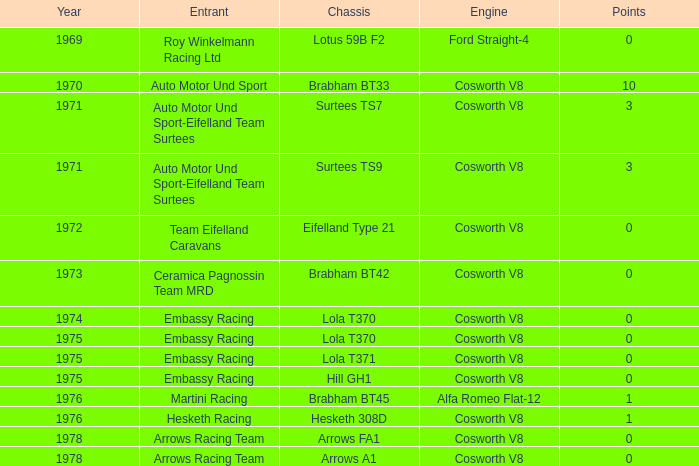What was the aggregate number of points in 1978 with a chassis of arrows fa1? 0.0. Could you parse the entire table as a dict? {'header': ['Year', 'Entrant', 'Chassis', 'Engine', 'Points'], 'rows': [['1969', 'Roy Winkelmann Racing Ltd', 'Lotus 59B F2', 'Ford Straight-4', '0'], ['1970', 'Auto Motor Und Sport', 'Brabham BT33', 'Cosworth V8', '10'], ['1971', 'Auto Motor Und Sport-Eifelland Team Surtees', 'Surtees TS7', 'Cosworth V8', '3'], ['1971', 'Auto Motor Und Sport-Eifelland Team Surtees', 'Surtees TS9', 'Cosworth V8', '3'], ['1972', 'Team Eifelland Caravans', 'Eifelland Type 21', 'Cosworth V8', '0'], ['1973', 'Ceramica Pagnossin Team MRD', 'Brabham BT42', 'Cosworth V8', '0'], ['1974', 'Embassy Racing', 'Lola T370', 'Cosworth V8', '0'], ['1975', 'Embassy Racing', 'Lola T370', 'Cosworth V8', '0'], ['1975', 'Embassy Racing', 'Lola T371', 'Cosworth V8', '0'], ['1975', 'Embassy Racing', 'Hill GH1', 'Cosworth V8', '0'], ['1976', 'Martini Racing', 'Brabham BT45', 'Alfa Romeo Flat-12', '1'], ['1976', 'Hesketh Racing', 'Hesketh 308D', 'Cosworth V8', '1'], ['1978', 'Arrows Racing Team', 'Arrows FA1', 'Cosworth V8', '0'], ['1978', 'Arrows Racing Team', 'Arrows A1', 'Cosworth V8', '0']]} 